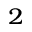<formula> <loc_0><loc_0><loc_500><loc_500>^ { 2 }</formula> 